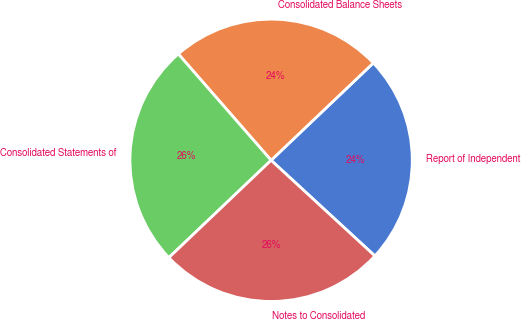Convert chart to OTSL. <chart><loc_0><loc_0><loc_500><loc_500><pie_chart><fcel>Report of Independent<fcel>Consolidated Balance Sheets<fcel>Consolidated Statements of<fcel>Notes to Consolidated<nl><fcel>23.96%<fcel>24.31%<fcel>25.69%<fcel>26.04%<nl></chart> 